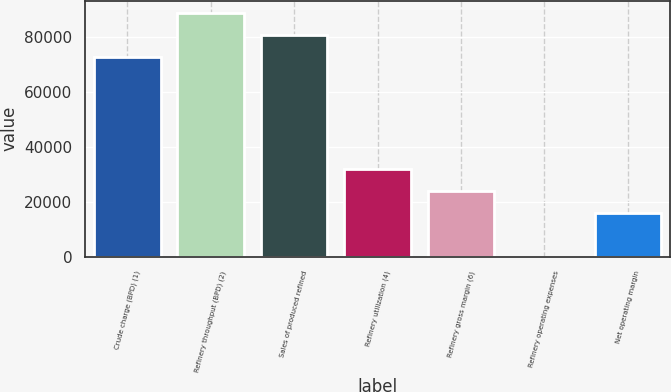<chart> <loc_0><loc_0><loc_500><loc_500><bar_chart><fcel>Crude charge (BPD) (1)<fcel>Refinery throughput (BPD) (2)<fcel>Sales of produced refined<fcel>Refinery utilization (4)<fcel>Refinery gross margin (6)<fcel>Refinery operating expenses<fcel>Net operating margin<nl><fcel>72890<fcel>88883.7<fcel>80886.9<fcel>31998.8<fcel>24001.9<fcel>11.28<fcel>16005<nl></chart> 